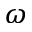<formula> <loc_0><loc_0><loc_500><loc_500>\omega</formula> 